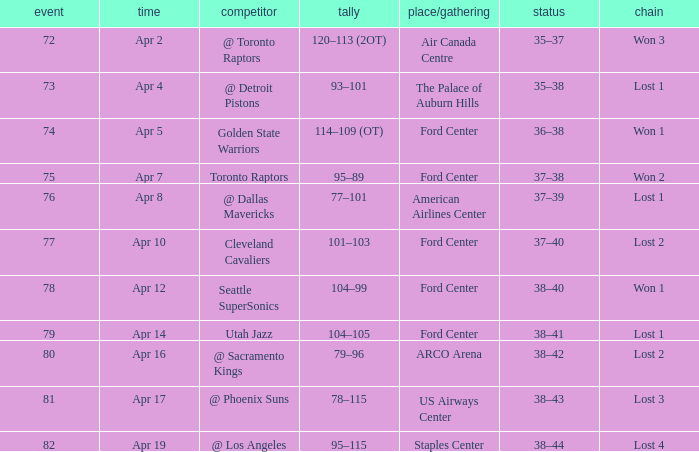Who was the opponent for game 75? Toronto Raptors. 